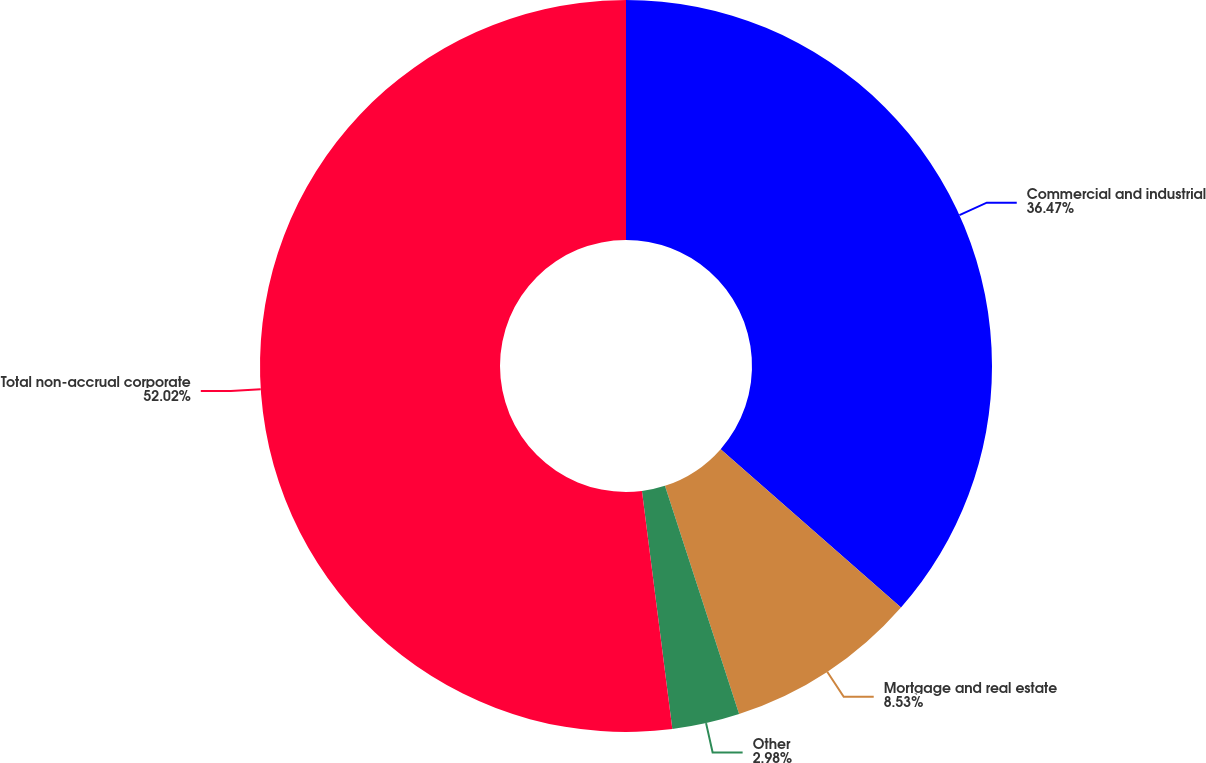<chart> <loc_0><loc_0><loc_500><loc_500><pie_chart><fcel>Commercial and industrial<fcel>Mortgage and real estate<fcel>Other<fcel>Total non-accrual corporate<nl><fcel>36.47%<fcel>8.53%<fcel>2.98%<fcel>52.02%<nl></chart> 